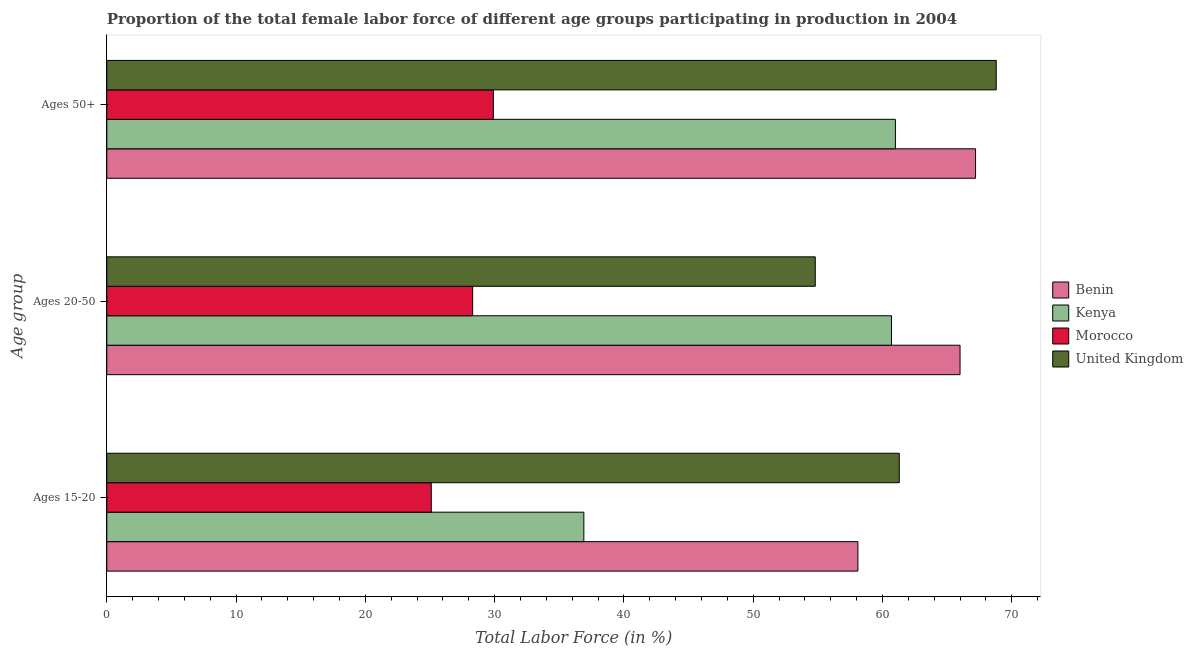Are the number of bars per tick equal to the number of legend labels?
Give a very brief answer. Yes. Are the number of bars on each tick of the Y-axis equal?
Give a very brief answer. Yes. How many bars are there on the 2nd tick from the bottom?
Provide a succinct answer. 4. What is the label of the 2nd group of bars from the top?
Your response must be concise. Ages 20-50. What is the percentage of female labor force within the age group 20-50 in Morocco?
Your answer should be very brief. 28.3. Across all countries, what is the minimum percentage of female labor force within the age group 15-20?
Offer a very short reply. 25.1. In which country was the percentage of female labor force within the age group 20-50 maximum?
Ensure brevity in your answer.  Benin. In which country was the percentage of female labor force within the age group 15-20 minimum?
Your answer should be compact. Morocco. What is the total percentage of female labor force within the age group 15-20 in the graph?
Keep it short and to the point. 181.4. What is the difference between the percentage of female labor force above age 50 in Morocco and that in United Kingdom?
Make the answer very short. -38.9. What is the difference between the percentage of female labor force within the age group 20-50 in Kenya and the percentage of female labor force above age 50 in Morocco?
Provide a short and direct response. 30.8. What is the average percentage of female labor force above age 50 per country?
Your response must be concise. 56.72. What is the difference between the percentage of female labor force within the age group 20-50 and percentage of female labor force within the age group 15-20 in Morocco?
Provide a short and direct response. 3.2. What is the ratio of the percentage of female labor force above age 50 in Morocco to that in Kenya?
Your answer should be compact. 0.49. Is the percentage of female labor force above age 50 in Morocco less than that in Benin?
Your response must be concise. Yes. What is the difference between the highest and the second highest percentage of female labor force within the age group 15-20?
Your response must be concise. 3.2. What is the difference between the highest and the lowest percentage of female labor force above age 50?
Offer a very short reply. 38.9. In how many countries, is the percentage of female labor force above age 50 greater than the average percentage of female labor force above age 50 taken over all countries?
Offer a terse response. 3. What does the 2nd bar from the bottom in Ages 20-50 represents?
Your answer should be compact. Kenya. How many bars are there?
Offer a very short reply. 12. How many countries are there in the graph?
Your response must be concise. 4. What is the difference between two consecutive major ticks on the X-axis?
Give a very brief answer. 10. Are the values on the major ticks of X-axis written in scientific E-notation?
Make the answer very short. No. Does the graph contain any zero values?
Ensure brevity in your answer.  No. Does the graph contain grids?
Offer a terse response. No. How many legend labels are there?
Your response must be concise. 4. What is the title of the graph?
Your answer should be compact. Proportion of the total female labor force of different age groups participating in production in 2004. What is the label or title of the X-axis?
Offer a terse response. Total Labor Force (in %). What is the label or title of the Y-axis?
Provide a short and direct response. Age group. What is the Total Labor Force (in %) of Benin in Ages 15-20?
Offer a very short reply. 58.1. What is the Total Labor Force (in %) of Kenya in Ages 15-20?
Keep it short and to the point. 36.9. What is the Total Labor Force (in %) in Morocco in Ages 15-20?
Your answer should be compact. 25.1. What is the Total Labor Force (in %) of United Kingdom in Ages 15-20?
Give a very brief answer. 61.3. What is the Total Labor Force (in %) of Kenya in Ages 20-50?
Your response must be concise. 60.7. What is the Total Labor Force (in %) of Morocco in Ages 20-50?
Provide a short and direct response. 28.3. What is the Total Labor Force (in %) of United Kingdom in Ages 20-50?
Offer a terse response. 54.8. What is the Total Labor Force (in %) of Benin in Ages 50+?
Make the answer very short. 67.2. What is the Total Labor Force (in %) in Kenya in Ages 50+?
Your response must be concise. 61. What is the Total Labor Force (in %) in Morocco in Ages 50+?
Offer a terse response. 29.9. What is the Total Labor Force (in %) of United Kingdom in Ages 50+?
Provide a succinct answer. 68.8. Across all Age group, what is the maximum Total Labor Force (in %) in Benin?
Offer a very short reply. 67.2. Across all Age group, what is the maximum Total Labor Force (in %) of Kenya?
Offer a terse response. 61. Across all Age group, what is the maximum Total Labor Force (in %) of Morocco?
Your answer should be compact. 29.9. Across all Age group, what is the maximum Total Labor Force (in %) in United Kingdom?
Provide a short and direct response. 68.8. Across all Age group, what is the minimum Total Labor Force (in %) in Benin?
Your answer should be compact. 58.1. Across all Age group, what is the minimum Total Labor Force (in %) of Kenya?
Provide a succinct answer. 36.9. Across all Age group, what is the minimum Total Labor Force (in %) of Morocco?
Your answer should be very brief. 25.1. Across all Age group, what is the minimum Total Labor Force (in %) of United Kingdom?
Your answer should be compact. 54.8. What is the total Total Labor Force (in %) of Benin in the graph?
Provide a short and direct response. 191.3. What is the total Total Labor Force (in %) in Kenya in the graph?
Provide a short and direct response. 158.6. What is the total Total Labor Force (in %) in Morocco in the graph?
Provide a succinct answer. 83.3. What is the total Total Labor Force (in %) of United Kingdom in the graph?
Keep it short and to the point. 184.9. What is the difference between the Total Labor Force (in %) in Benin in Ages 15-20 and that in Ages 20-50?
Offer a very short reply. -7.9. What is the difference between the Total Labor Force (in %) in Kenya in Ages 15-20 and that in Ages 20-50?
Make the answer very short. -23.8. What is the difference between the Total Labor Force (in %) in Morocco in Ages 15-20 and that in Ages 20-50?
Keep it short and to the point. -3.2. What is the difference between the Total Labor Force (in %) in United Kingdom in Ages 15-20 and that in Ages 20-50?
Provide a succinct answer. 6.5. What is the difference between the Total Labor Force (in %) in Kenya in Ages 15-20 and that in Ages 50+?
Offer a terse response. -24.1. What is the difference between the Total Labor Force (in %) in Benin in Ages 20-50 and that in Ages 50+?
Your answer should be very brief. -1.2. What is the difference between the Total Labor Force (in %) in Morocco in Ages 20-50 and that in Ages 50+?
Keep it short and to the point. -1.6. What is the difference between the Total Labor Force (in %) in Benin in Ages 15-20 and the Total Labor Force (in %) in Kenya in Ages 20-50?
Offer a terse response. -2.6. What is the difference between the Total Labor Force (in %) of Benin in Ages 15-20 and the Total Labor Force (in %) of Morocco in Ages 20-50?
Your answer should be very brief. 29.8. What is the difference between the Total Labor Force (in %) in Kenya in Ages 15-20 and the Total Labor Force (in %) in United Kingdom in Ages 20-50?
Provide a short and direct response. -17.9. What is the difference between the Total Labor Force (in %) of Morocco in Ages 15-20 and the Total Labor Force (in %) of United Kingdom in Ages 20-50?
Give a very brief answer. -29.7. What is the difference between the Total Labor Force (in %) of Benin in Ages 15-20 and the Total Labor Force (in %) of Kenya in Ages 50+?
Offer a terse response. -2.9. What is the difference between the Total Labor Force (in %) in Benin in Ages 15-20 and the Total Labor Force (in %) in Morocco in Ages 50+?
Offer a terse response. 28.2. What is the difference between the Total Labor Force (in %) in Benin in Ages 15-20 and the Total Labor Force (in %) in United Kingdom in Ages 50+?
Your answer should be compact. -10.7. What is the difference between the Total Labor Force (in %) of Kenya in Ages 15-20 and the Total Labor Force (in %) of Morocco in Ages 50+?
Offer a very short reply. 7. What is the difference between the Total Labor Force (in %) in Kenya in Ages 15-20 and the Total Labor Force (in %) in United Kingdom in Ages 50+?
Ensure brevity in your answer.  -31.9. What is the difference between the Total Labor Force (in %) in Morocco in Ages 15-20 and the Total Labor Force (in %) in United Kingdom in Ages 50+?
Offer a terse response. -43.7. What is the difference between the Total Labor Force (in %) in Benin in Ages 20-50 and the Total Labor Force (in %) in Morocco in Ages 50+?
Make the answer very short. 36.1. What is the difference between the Total Labor Force (in %) in Benin in Ages 20-50 and the Total Labor Force (in %) in United Kingdom in Ages 50+?
Your response must be concise. -2.8. What is the difference between the Total Labor Force (in %) in Kenya in Ages 20-50 and the Total Labor Force (in %) in Morocco in Ages 50+?
Offer a terse response. 30.8. What is the difference between the Total Labor Force (in %) in Morocco in Ages 20-50 and the Total Labor Force (in %) in United Kingdom in Ages 50+?
Your response must be concise. -40.5. What is the average Total Labor Force (in %) in Benin per Age group?
Give a very brief answer. 63.77. What is the average Total Labor Force (in %) in Kenya per Age group?
Offer a very short reply. 52.87. What is the average Total Labor Force (in %) in Morocco per Age group?
Offer a very short reply. 27.77. What is the average Total Labor Force (in %) in United Kingdom per Age group?
Your response must be concise. 61.63. What is the difference between the Total Labor Force (in %) in Benin and Total Labor Force (in %) in Kenya in Ages 15-20?
Provide a succinct answer. 21.2. What is the difference between the Total Labor Force (in %) in Kenya and Total Labor Force (in %) in United Kingdom in Ages 15-20?
Ensure brevity in your answer.  -24.4. What is the difference between the Total Labor Force (in %) of Morocco and Total Labor Force (in %) of United Kingdom in Ages 15-20?
Offer a terse response. -36.2. What is the difference between the Total Labor Force (in %) of Benin and Total Labor Force (in %) of Morocco in Ages 20-50?
Your answer should be compact. 37.7. What is the difference between the Total Labor Force (in %) in Kenya and Total Labor Force (in %) in Morocco in Ages 20-50?
Ensure brevity in your answer.  32.4. What is the difference between the Total Labor Force (in %) of Morocco and Total Labor Force (in %) of United Kingdom in Ages 20-50?
Provide a succinct answer. -26.5. What is the difference between the Total Labor Force (in %) in Benin and Total Labor Force (in %) in Kenya in Ages 50+?
Your response must be concise. 6.2. What is the difference between the Total Labor Force (in %) in Benin and Total Labor Force (in %) in Morocco in Ages 50+?
Provide a succinct answer. 37.3. What is the difference between the Total Labor Force (in %) of Kenya and Total Labor Force (in %) of Morocco in Ages 50+?
Offer a very short reply. 31.1. What is the difference between the Total Labor Force (in %) of Kenya and Total Labor Force (in %) of United Kingdom in Ages 50+?
Keep it short and to the point. -7.8. What is the difference between the Total Labor Force (in %) in Morocco and Total Labor Force (in %) in United Kingdom in Ages 50+?
Provide a short and direct response. -38.9. What is the ratio of the Total Labor Force (in %) of Benin in Ages 15-20 to that in Ages 20-50?
Your response must be concise. 0.88. What is the ratio of the Total Labor Force (in %) in Kenya in Ages 15-20 to that in Ages 20-50?
Offer a terse response. 0.61. What is the ratio of the Total Labor Force (in %) in Morocco in Ages 15-20 to that in Ages 20-50?
Give a very brief answer. 0.89. What is the ratio of the Total Labor Force (in %) of United Kingdom in Ages 15-20 to that in Ages 20-50?
Offer a terse response. 1.12. What is the ratio of the Total Labor Force (in %) in Benin in Ages 15-20 to that in Ages 50+?
Your answer should be very brief. 0.86. What is the ratio of the Total Labor Force (in %) in Kenya in Ages 15-20 to that in Ages 50+?
Give a very brief answer. 0.6. What is the ratio of the Total Labor Force (in %) of Morocco in Ages 15-20 to that in Ages 50+?
Provide a succinct answer. 0.84. What is the ratio of the Total Labor Force (in %) in United Kingdom in Ages 15-20 to that in Ages 50+?
Provide a short and direct response. 0.89. What is the ratio of the Total Labor Force (in %) in Benin in Ages 20-50 to that in Ages 50+?
Offer a terse response. 0.98. What is the ratio of the Total Labor Force (in %) of Kenya in Ages 20-50 to that in Ages 50+?
Your answer should be compact. 1. What is the ratio of the Total Labor Force (in %) in Morocco in Ages 20-50 to that in Ages 50+?
Provide a short and direct response. 0.95. What is the ratio of the Total Labor Force (in %) of United Kingdom in Ages 20-50 to that in Ages 50+?
Provide a succinct answer. 0.8. What is the difference between the highest and the second highest Total Labor Force (in %) of Benin?
Offer a terse response. 1.2. What is the difference between the highest and the second highest Total Labor Force (in %) of Kenya?
Provide a short and direct response. 0.3. What is the difference between the highest and the second highest Total Labor Force (in %) in Morocco?
Offer a terse response. 1.6. What is the difference between the highest and the lowest Total Labor Force (in %) in Kenya?
Make the answer very short. 24.1. What is the difference between the highest and the lowest Total Labor Force (in %) in United Kingdom?
Offer a terse response. 14. 